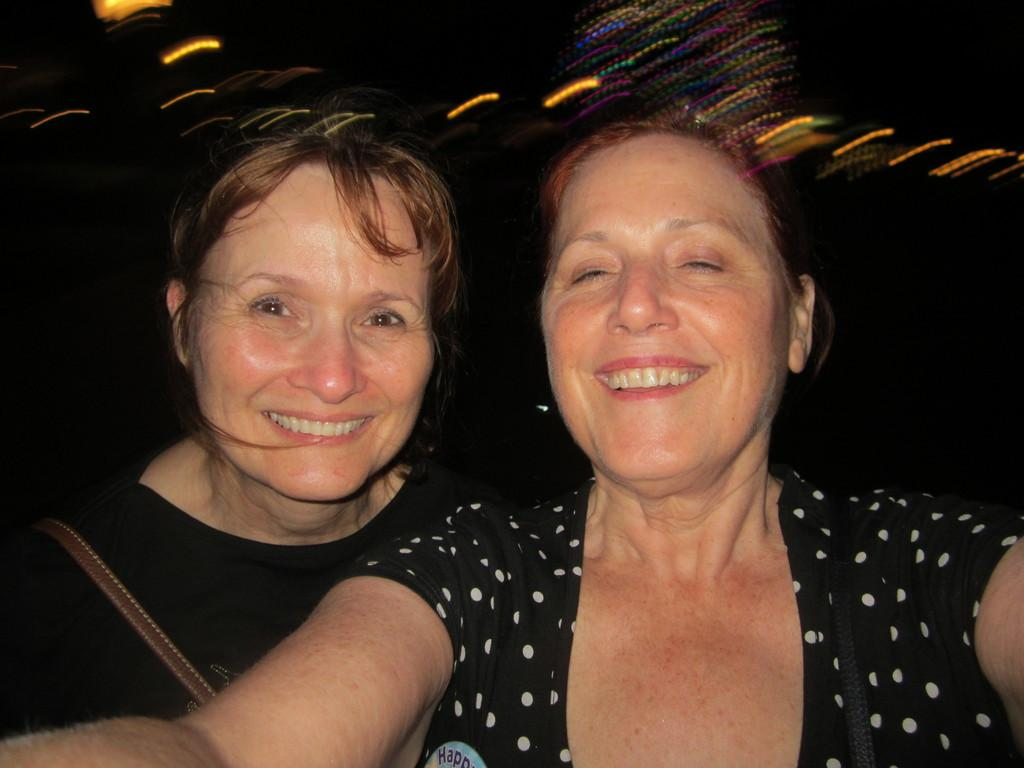How many people are in the image? There are two women in the image. What is the facial expression of the women in the image? The women are smiling. What can be observed about the background of the image? The background of the image is dark. What can be seen in addition to the women in the image? There are lights visible in the image. What language are the women speaking in the image? The image does not provide any information about the language being spoken by the women. Where are the women going on vacation in the image? There is no indication of a vacation or any travel plans in the image. 